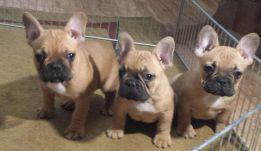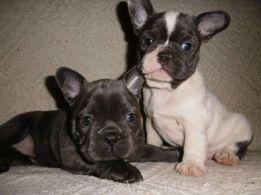The first image is the image on the left, the second image is the image on the right. Assess this claim about the two images: "Both dogs are standing on all four feet.". Correct or not? Answer yes or no. No. The first image is the image on the left, the second image is the image on the right. Evaluate the accuracy of this statement regarding the images: "There are at most two dogs.". Is it true? Answer yes or no. No. 